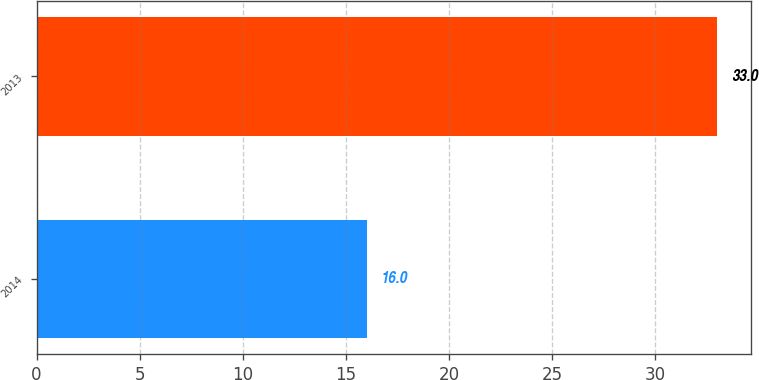<chart> <loc_0><loc_0><loc_500><loc_500><bar_chart><fcel>2014<fcel>2013<nl><fcel>16<fcel>33<nl></chart> 